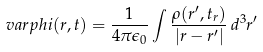<formula> <loc_0><loc_0><loc_500><loc_500>\ v a r p h i ( r , t ) = { \frac { 1 } { 4 \pi \epsilon _ { 0 } } } \int { \frac { \rho ( r ^ { \prime } , t _ { r } ) } { | r - r ^ { \prime } | } } \, d ^ { 3 } r ^ { \prime }</formula> 